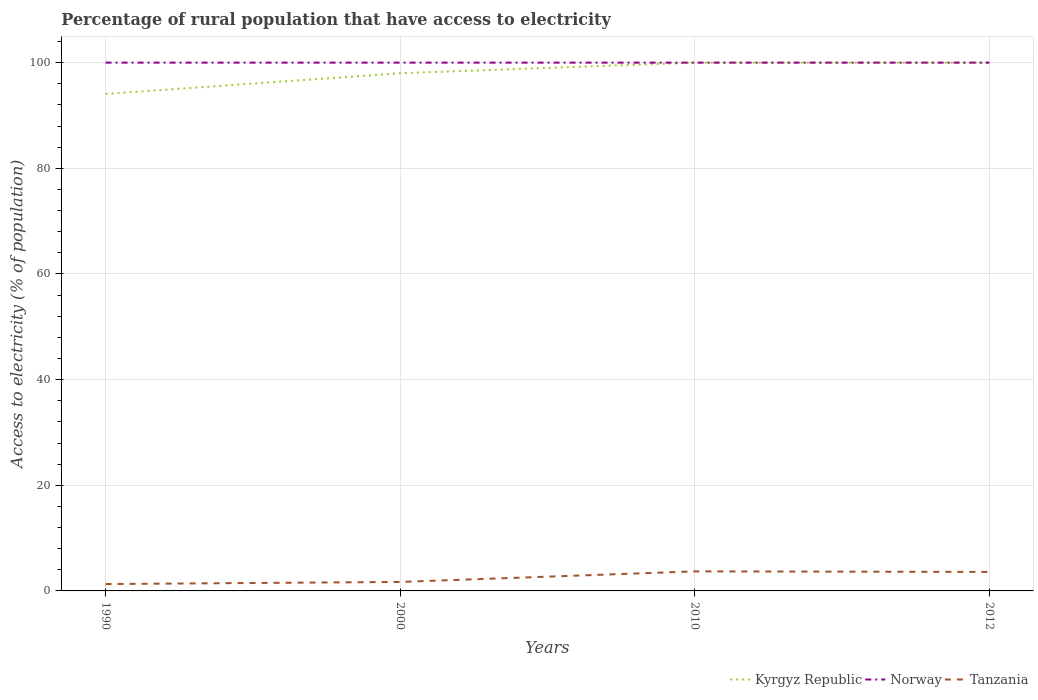Does the line corresponding to Kyrgyz Republic intersect with the line corresponding to Tanzania?
Make the answer very short. No. What is the difference between the highest and the second highest percentage of rural population that have access to electricity in Tanzania?
Your response must be concise. 2.4. How many lines are there?
Make the answer very short. 3. How many years are there in the graph?
Keep it short and to the point. 4. Are the values on the major ticks of Y-axis written in scientific E-notation?
Ensure brevity in your answer.  No. What is the title of the graph?
Provide a succinct answer. Percentage of rural population that have access to electricity. What is the label or title of the X-axis?
Give a very brief answer. Years. What is the label or title of the Y-axis?
Offer a terse response. Access to electricity (% of population). What is the Access to electricity (% of population) of Kyrgyz Republic in 1990?
Offer a terse response. 94.08. What is the Access to electricity (% of population) in Norway in 1990?
Provide a succinct answer. 100. What is the Access to electricity (% of population) in Kyrgyz Republic in 2000?
Your response must be concise. 98. What is the Access to electricity (% of population) of Norway in 2000?
Provide a succinct answer. 100. What is the Access to electricity (% of population) in Tanzania in 2010?
Make the answer very short. 3.7. What is the Access to electricity (% of population) of Tanzania in 2012?
Your response must be concise. 3.6. Across all years, what is the maximum Access to electricity (% of population) in Kyrgyz Republic?
Provide a short and direct response. 100. Across all years, what is the maximum Access to electricity (% of population) in Norway?
Ensure brevity in your answer.  100. Across all years, what is the maximum Access to electricity (% of population) in Tanzania?
Your answer should be compact. 3.7. Across all years, what is the minimum Access to electricity (% of population) of Kyrgyz Republic?
Ensure brevity in your answer.  94.08. What is the total Access to electricity (% of population) in Kyrgyz Republic in the graph?
Your response must be concise. 392.08. What is the difference between the Access to electricity (% of population) of Kyrgyz Republic in 1990 and that in 2000?
Give a very brief answer. -3.92. What is the difference between the Access to electricity (% of population) in Norway in 1990 and that in 2000?
Give a very brief answer. 0. What is the difference between the Access to electricity (% of population) of Kyrgyz Republic in 1990 and that in 2010?
Your answer should be very brief. -5.92. What is the difference between the Access to electricity (% of population) in Norway in 1990 and that in 2010?
Your response must be concise. 0. What is the difference between the Access to electricity (% of population) of Kyrgyz Republic in 1990 and that in 2012?
Provide a succinct answer. -5.92. What is the difference between the Access to electricity (% of population) in Kyrgyz Republic in 2000 and that in 2010?
Keep it short and to the point. -2. What is the difference between the Access to electricity (% of population) in Norway in 2000 and that in 2010?
Provide a succinct answer. 0. What is the difference between the Access to electricity (% of population) of Kyrgyz Republic in 2000 and that in 2012?
Provide a short and direct response. -2. What is the difference between the Access to electricity (% of population) of Norway in 2000 and that in 2012?
Make the answer very short. 0. What is the difference between the Access to electricity (% of population) of Norway in 2010 and that in 2012?
Provide a succinct answer. 0. What is the difference between the Access to electricity (% of population) of Tanzania in 2010 and that in 2012?
Make the answer very short. 0.1. What is the difference between the Access to electricity (% of population) in Kyrgyz Republic in 1990 and the Access to electricity (% of population) in Norway in 2000?
Give a very brief answer. -5.92. What is the difference between the Access to electricity (% of population) in Kyrgyz Republic in 1990 and the Access to electricity (% of population) in Tanzania in 2000?
Provide a short and direct response. 92.38. What is the difference between the Access to electricity (% of population) of Norway in 1990 and the Access to electricity (% of population) of Tanzania in 2000?
Offer a terse response. 98.3. What is the difference between the Access to electricity (% of population) of Kyrgyz Republic in 1990 and the Access to electricity (% of population) of Norway in 2010?
Offer a terse response. -5.92. What is the difference between the Access to electricity (% of population) in Kyrgyz Republic in 1990 and the Access to electricity (% of population) in Tanzania in 2010?
Keep it short and to the point. 90.38. What is the difference between the Access to electricity (% of population) in Norway in 1990 and the Access to electricity (% of population) in Tanzania in 2010?
Your answer should be compact. 96.3. What is the difference between the Access to electricity (% of population) in Kyrgyz Republic in 1990 and the Access to electricity (% of population) in Norway in 2012?
Provide a short and direct response. -5.92. What is the difference between the Access to electricity (% of population) of Kyrgyz Republic in 1990 and the Access to electricity (% of population) of Tanzania in 2012?
Make the answer very short. 90.48. What is the difference between the Access to electricity (% of population) of Norway in 1990 and the Access to electricity (% of population) of Tanzania in 2012?
Ensure brevity in your answer.  96.4. What is the difference between the Access to electricity (% of population) of Kyrgyz Republic in 2000 and the Access to electricity (% of population) of Tanzania in 2010?
Offer a terse response. 94.3. What is the difference between the Access to electricity (% of population) of Norway in 2000 and the Access to electricity (% of population) of Tanzania in 2010?
Ensure brevity in your answer.  96.3. What is the difference between the Access to electricity (% of population) of Kyrgyz Republic in 2000 and the Access to electricity (% of population) of Tanzania in 2012?
Provide a succinct answer. 94.4. What is the difference between the Access to electricity (% of population) of Norway in 2000 and the Access to electricity (% of population) of Tanzania in 2012?
Make the answer very short. 96.4. What is the difference between the Access to electricity (% of population) of Kyrgyz Republic in 2010 and the Access to electricity (% of population) of Norway in 2012?
Your response must be concise. 0. What is the difference between the Access to electricity (% of population) in Kyrgyz Republic in 2010 and the Access to electricity (% of population) in Tanzania in 2012?
Offer a very short reply. 96.4. What is the difference between the Access to electricity (% of population) in Norway in 2010 and the Access to electricity (% of population) in Tanzania in 2012?
Offer a terse response. 96.4. What is the average Access to electricity (% of population) in Kyrgyz Republic per year?
Offer a very short reply. 98.02. What is the average Access to electricity (% of population) of Norway per year?
Offer a very short reply. 100. What is the average Access to electricity (% of population) in Tanzania per year?
Provide a short and direct response. 2.58. In the year 1990, what is the difference between the Access to electricity (% of population) in Kyrgyz Republic and Access to electricity (% of population) in Norway?
Your response must be concise. -5.92. In the year 1990, what is the difference between the Access to electricity (% of population) of Kyrgyz Republic and Access to electricity (% of population) of Tanzania?
Give a very brief answer. 92.78. In the year 1990, what is the difference between the Access to electricity (% of population) of Norway and Access to electricity (% of population) of Tanzania?
Provide a short and direct response. 98.7. In the year 2000, what is the difference between the Access to electricity (% of population) of Kyrgyz Republic and Access to electricity (% of population) of Tanzania?
Offer a terse response. 96.3. In the year 2000, what is the difference between the Access to electricity (% of population) in Norway and Access to electricity (% of population) in Tanzania?
Your answer should be very brief. 98.3. In the year 2010, what is the difference between the Access to electricity (% of population) of Kyrgyz Republic and Access to electricity (% of population) of Norway?
Give a very brief answer. 0. In the year 2010, what is the difference between the Access to electricity (% of population) of Kyrgyz Republic and Access to electricity (% of population) of Tanzania?
Make the answer very short. 96.3. In the year 2010, what is the difference between the Access to electricity (% of population) of Norway and Access to electricity (% of population) of Tanzania?
Provide a succinct answer. 96.3. In the year 2012, what is the difference between the Access to electricity (% of population) in Kyrgyz Republic and Access to electricity (% of population) in Tanzania?
Your response must be concise. 96.4. In the year 2012, what is the difference between the Access to electricity (% of population) of Norway and Access to electricity (% of population) of Tanzania?
Offer a very short reply. 96.4. What is the ratio of the Access to electricity (% of population) in Tanzania in 1990 to that in 2000?
Give a very brief answer. 0.76. What is the ratio of the Access to electricity (% of population) of Kyrgyz Republic in 1990 to that in 2010?
Your response must be concise. 0.94. What is the ratio of the Access to electricity (% of population) in Norway in 1990 to that in 2010?
Give a very brief answer. 1. What is the ratio of the Access to electricity (% of population) of Tanzania in 1990 to that in 2010?
Keep it short and to the point. 0.35. What is the ratio of the Access to electricity (% of population) of Kyrgyz Republic in 1990 to that in 2012?
Keep it short and to the point. 0.94. What is the ratio of the Access to electricity (% of population) in Norway in 1990 to that in 2012?
Ensure brevity in your answer.  1. What is the ratio of the Access to electricity (% of population) in Tanzania in 1990 to that in 2012?
Give a very brief answer. 0.36. What is the ratio of the Access to electricity (% of population) in Kyrgyz Republic in 2000 to that in 2010?
Provide a succinct answer. 0.98. What is the ratio of the Access to electricity (% of population) of Norway in 2000 to that in 2010?
Give a very brief answer. 1. What is the ratio of the Access to electricity (% of population) in Tanzania in 2000 to that in 2010?
Keep it short and to the point. 0.46. What is the ratio of the Access to electricity (% of population) of Tanzania in 2000 to that in 2012?
Your response must be concise. 0.47. What is the ratio of the Access to electricity (% of population) of Kyrgyz Republic in 2010 to that in 2012?
Offer a terse response. 1. What is the ratio of the Access to electricity (% of population) in Norway in 2010 to that in 2012?
Ensure brevity in your answer.  1. What is the ratio of the Access to electricity (% of population) in Tanzania in 2010 to that in 2012?
Provide a short and direct response. 1.03. What is the difference between the highest and the second highest Access to electricity (% of population) of Kyrgyz Republic?
Provide a short and direct response. 0. What is the difference between the highest and the second highest Access to electricity (% of population) in Norway?
Your response must be concise. 0. What is the difference between the highest and the second highest Access to electricity (% of population) in Tanzania?
Give a very brief answer. 0.1. What is the difference between the highest and the lowest Access to electricity (% of population) in Kyrgyz Republic?
Offer a terse response. 5.92. What is the difference between the highest and the lowest Access to electricity (% of population) of Tanzania?
Give a very brief answer. 2.4. 